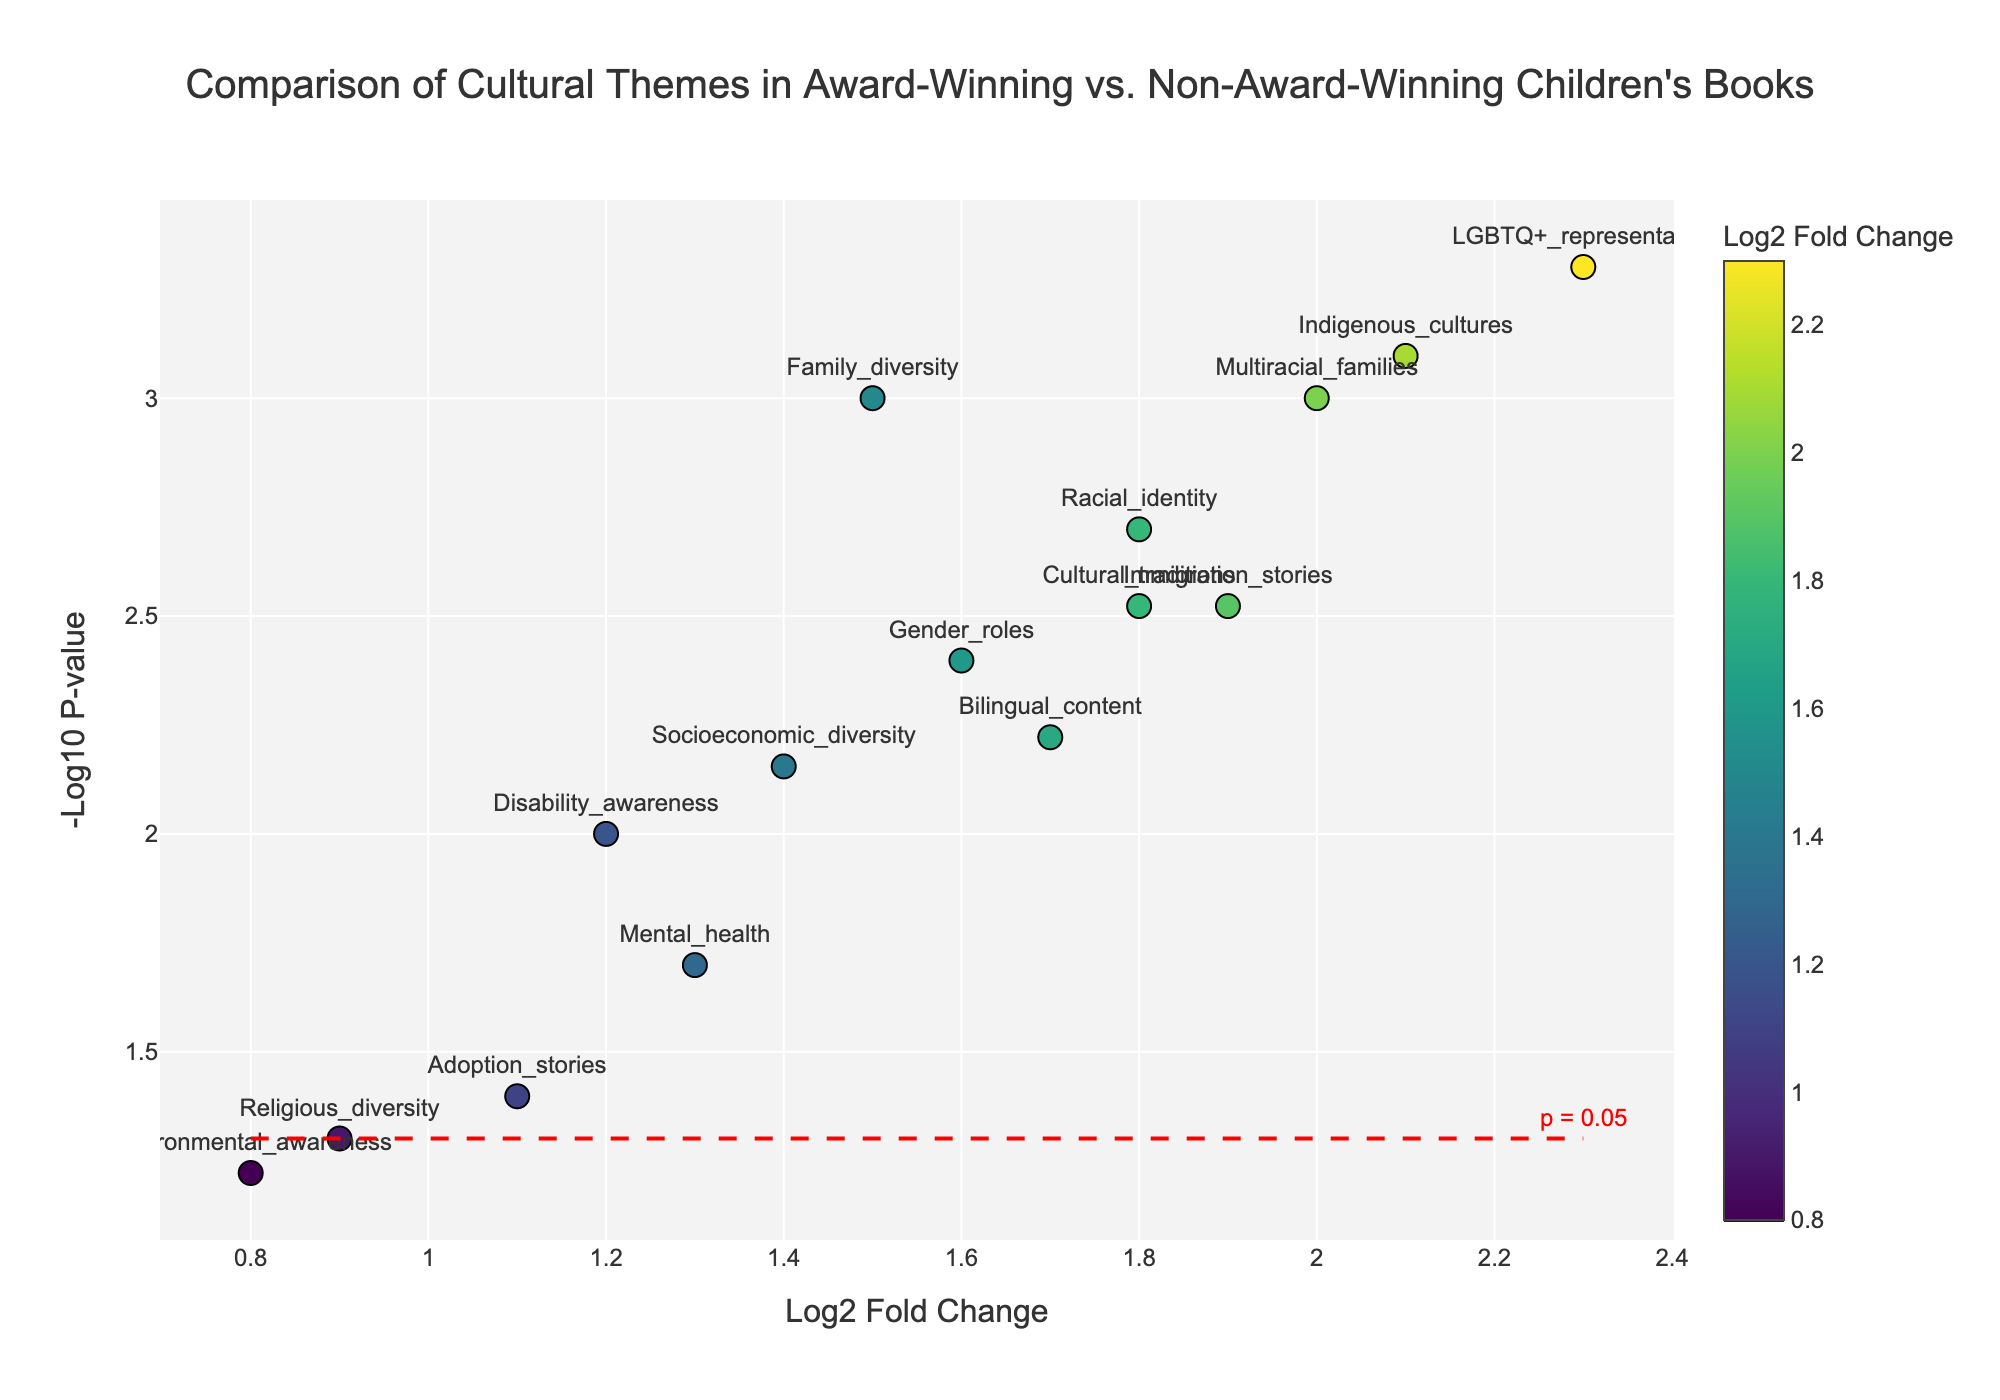What is the title of the plot? The title is displayed at the top of the plot.
Answer: Comparison of Cultural Themes in Award-Winning vs. Non-Award-Winning Children's Books How many book themes have a p-value less than 0.05? The horizontal red dash line represents the p-value significance threshold at 0.05. Count the number of data points above this line.
Answer: 13 Which book theme has the highest log2 fold change? The theme with the highest log2 fold change is the one located farthest to the right on the x-axis.
Answer: LGBTQ+ representation Which cultural theme has the lowest -log10 p-value? The theme with the lowest -log10 p-value will be the closest point to the x-axis.
Answer: Environmental awareness Is Racial identity more statistically significant than Socioeconomic diversity? Compare their -log10 p-values (y-axis), higher values indicate greater statistical significance.
Answer: Yes What are the log2 fold change and p-value for Gender roles? Hover over or read the marker for Gender roles.
Answer: Log2 fold change: 1.6, P-value: 0.004 Compare the log2 fold change of Family diversity and Mental health. Which is greater? Look at the x-axis values for Family diversity and Mental health. The one with a higher value is greater.
Answer: Family diversity Which cultural theme among Indigenous cultures, Immigration stories, and Multiracial families has the highest statistical significance? Compare the -log10 p-values (y-axis) for these themes. The higher value indicates greater significance.
Answer: Indigenous cultures How is the p-value for Religious diversity displayed on the plot? Find the point for Religious diversity and convert its -log10 p-value back to the p-value using the formula p-value = 10^(-log10 p-value).
Answer: 0.05 What observation can be made about the inclusion of themes such as "Adoption stories" and "Environmental awareness" based on their log2 fold change and -log10 p-value? Both themes have relatively low log2 fold change and are closer to the red dash line, indicating less significant difference and lower representation among award-winning books.
Answer: Less significant difference and lower representation among award-winning books 